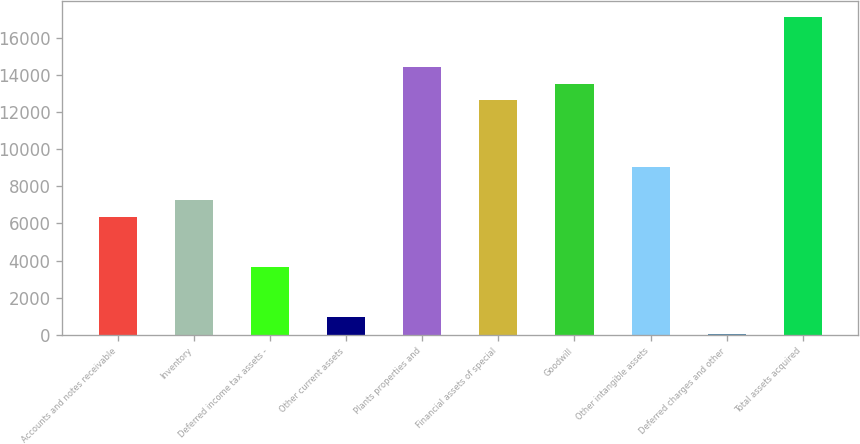<chart> <loc_0><loc_0><loc_500><loc_500><bar_chart><fcel>Accounts and notes receivable<fcel>Inventory<fcel>Deferred income tax assets -<fcel>Other current assets<fcel>Plants properties and<fcel>Financial assets of special<fcel>Goodwill<fcel>Other intangible assets<fcel>Deferred charges and other<fcel>Total assets acquired<nl><fcel>6340.7<fcel>7238.8<fcel>3646.4<fcel>952.1<fcel>14423.6<fcel>12627.4<fcel>13525.5<fcel>9035<fcel>54<fcel>17117.9<nl></chart> 